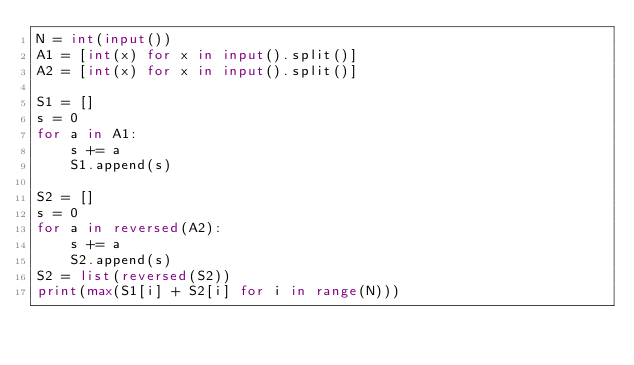Convert code to text. <code><loc_0><loc_0><loc_500><loc_500><_Python_>N = int(input())
A1 = [int(x) for x in input().split()]
A2 = [int(x) for x in input().split()]

S1 = []
s = 0
for a in A1:
    s += a
    S1.append(s)

S2 = []
s = 0
for a in reversed(A2):
    s += a
    S2.append(s)
S2 = list(reversed(S2))
print(max(S1[i] + S2[i] for i in range(N)))

</code> 